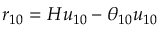<formula> <loc_0><loc_0><loc_500><loc_500>r _ { 1 0 } = H u _ { 1 0 } - \theta _ { 1 0 } u _ { 1 0 }</formula> 